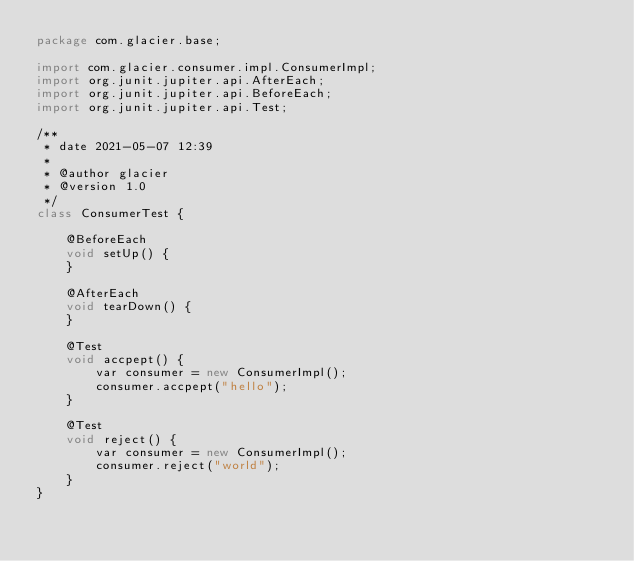<code> <loc_0><loc_0><loc_500><loc_500><_Java_>package com.glacier.base;

import com.glacier.consumer.impl.ConsumerImpl;
import org.junit.jupiter.api.AfterEach;
import org.junit.jupiter.api.BeforeEach;
import org.junit.jupiter.api.Test;

/**
 * date 2021-05-07 12:39
 *
 * @author glacier
 * @version 1.0
 */
class ConsumerTest {
    
    @BeforeEach
    void setUp() {
    }
    
    @AfterEach
    void tearDown() {
    }
    
    @Test
    void accpept() {
        var consumer = new ConsumerImpl();
        consumer.accpept("hello");
    }
    
    @Test
    void reject() {
        var consumer = new ConsumerImpl();
        consumer.reject("world");
    }
}
</code> 